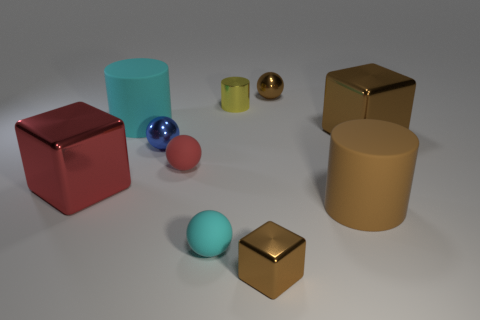Is the shape of the brown matte thing the same as the tiny object to the left of the red matte thing?
Keep it short and to the point. No. There is a large cylinder that is the same color as the small cube; what is its material?
Your answer should be compact. Rubber. There is a brown object that is behind the large cyan rubber thing; does it have the same shape as the cyan object that is in front of the red sphere?
Provide a succinct answer. Yes. There is a red sphere that is the same size as the blue metallic object; what is it made of?
Your answer should be compact. Rubber. Are the big cylinder on the right side of the tiny red sphere and the red object that is to the right of the tiny blue ball made of the same material?
Offer a terse response. Yes. What shape is the other brown object that is the same size as the brown matte object?
Offer a terse response. Cube. How many other things are the same color as the small shiny block?
Your response must be concise. 3. There is a big shiny block that is on the left side of the large brown metallic block; what is its color?
Your answer should be compact. Red. What number of other things are there of the same material as the red ball
Provide a short and direct response. 3. Are there more red things left of the small yellow metallic thing than cyan matte cylinders that are on the right side of the small brown block?
Provide a short and direct response. Yes. 